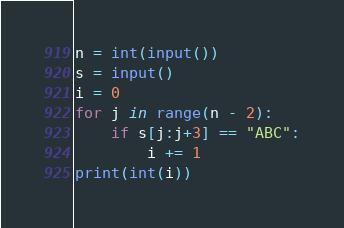Convert code to text. <code><loc_0><loc_0><loc_500><loc_500><_Python_>n = int(input())
s = input()
i = 0
for j in range(n - 2):
    if s[j:j+3] == "ABC":
        i += 1
print(int(i))</code> 